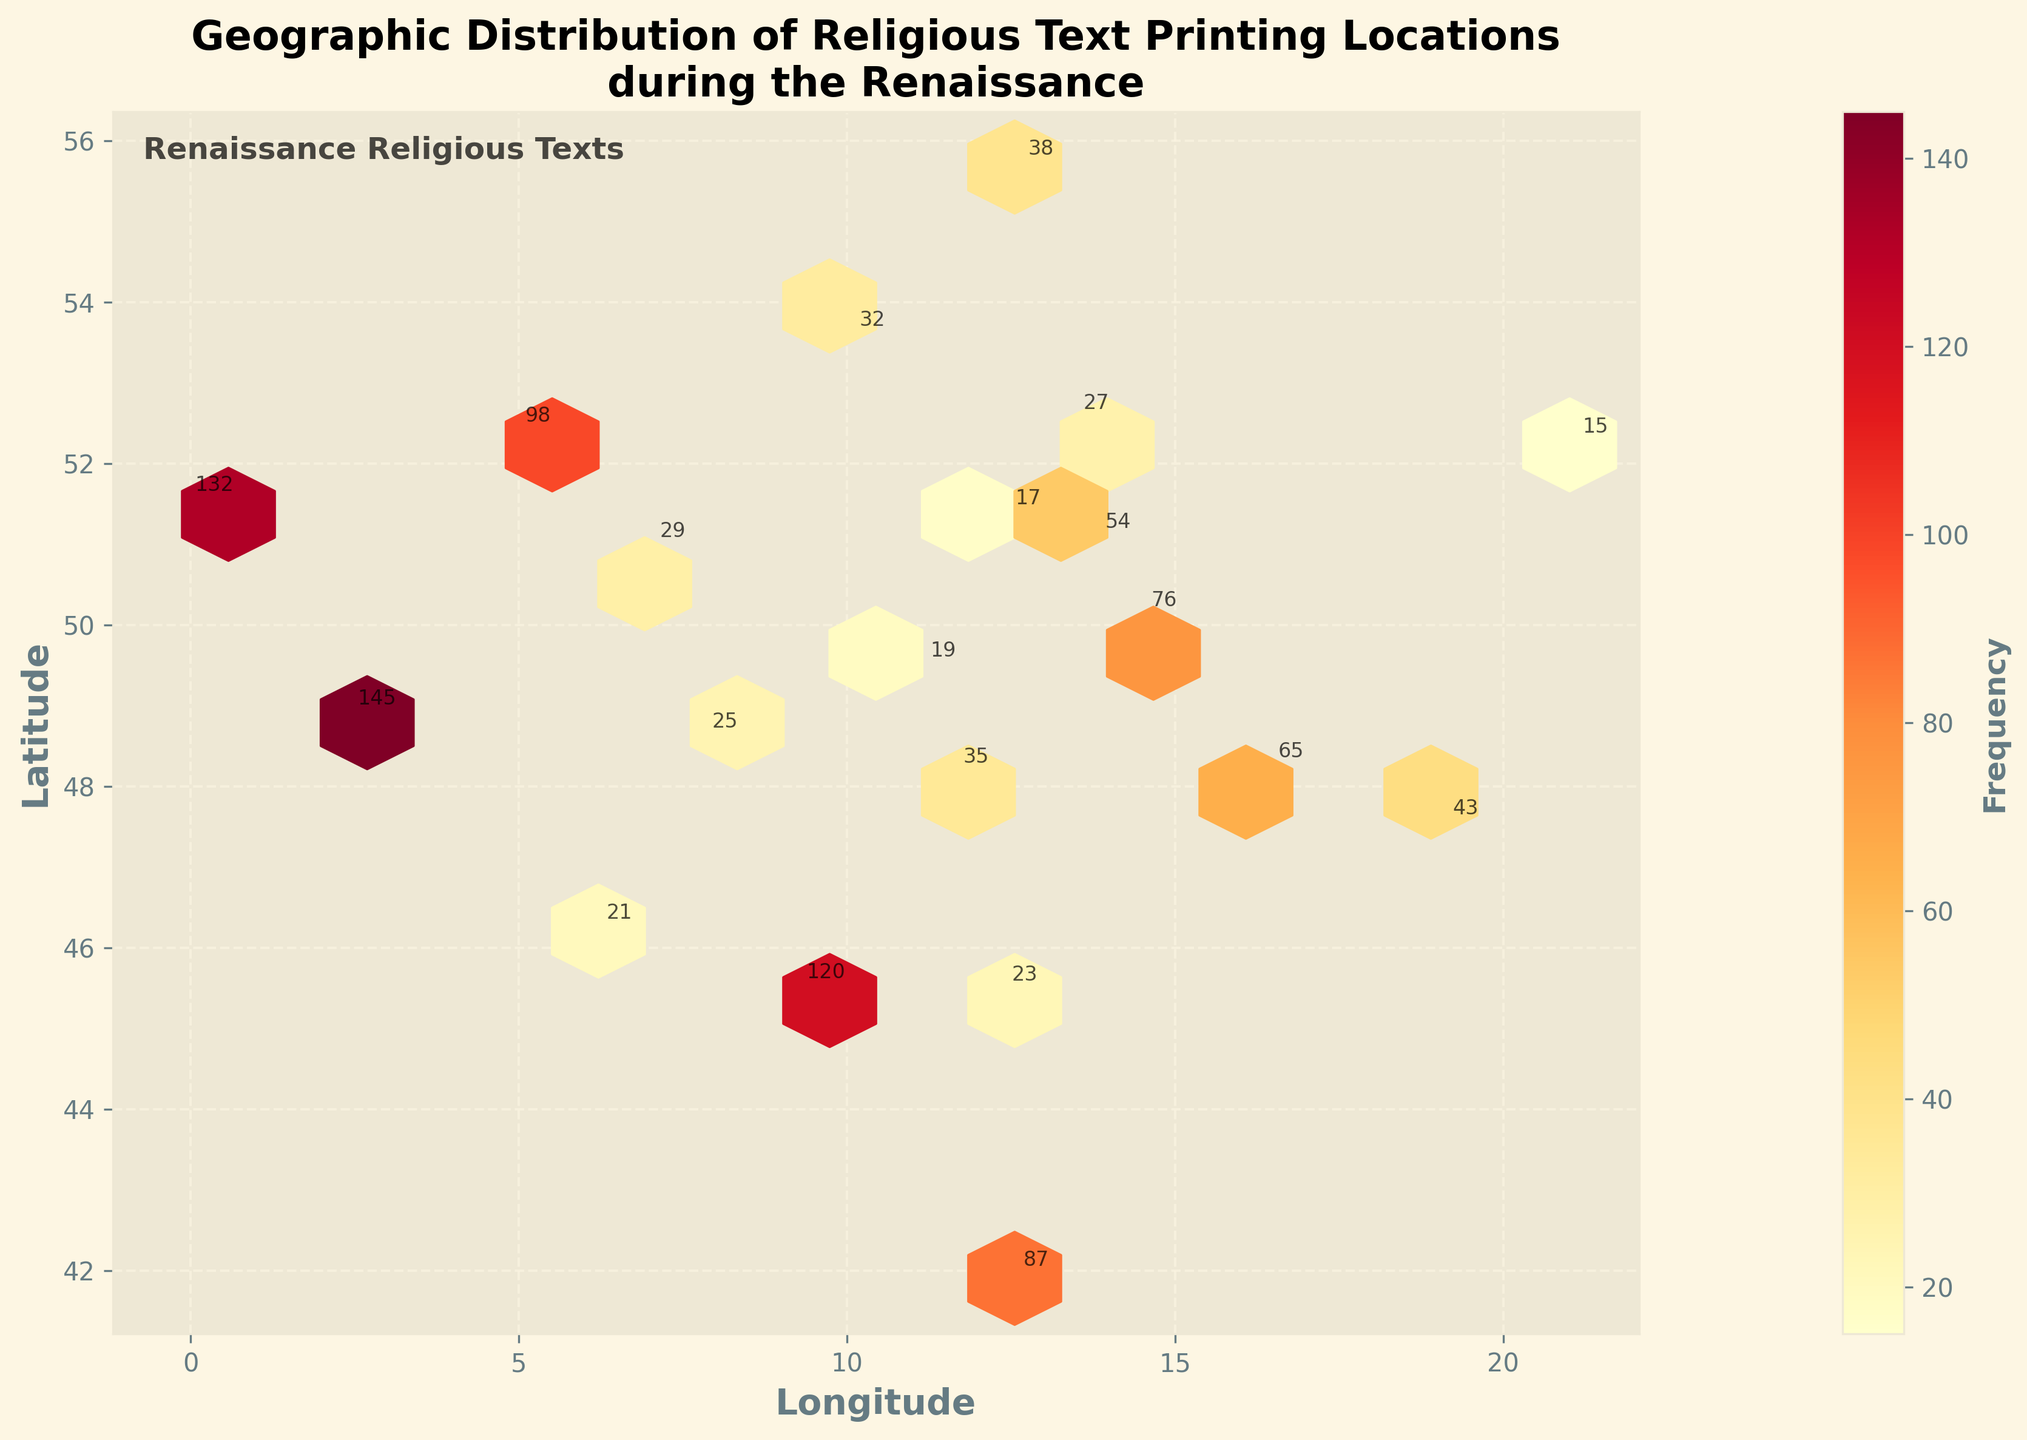What's the title of the figure? The title of the figure is prominently shown at the top.
Answer: Geographic Distribution of Religious Text Printing Locations during the Renaissance What does the colorbar represent? The colorbar indicates the frequency of religious texts printed at each location. It uses a gradient scale from light yellow (low frequency) to dark red (high frequency).
Answer: Frequency Which city has the highest frequency of printed religious texts? By looking at the highest color intensity (darkest red) and the city annotations, Paris (48.8566, 2.3522) has the highest frequency of 145.
Answer: Paris How many cities have a frequency of over 100? By checking the annotations for frequencies over 100, there are three cities: Paris (145), London (132), and Milan (120).
Answer: 3 Is there a city on the list with less than 20 printed texts? If yes, name one. By checking the frequency annotations, there is a city with less than 20 printed texts, such as Nuremberg (19).
Answer: Nuremberg Which latitude range contains the most densely packed printing locations? The densest cluster of hexagons appears between latitudes roughly 40 and 55 degrees, centered around cities like Paris and London.
Answer: 40-55 degrees What city is closest to the coordinate (41.9028, 12.4964), and what is its frequency? The city at this coordinate is Rome, as indicated by the annotation for the frequency. Rome has a frequency of 87.
Answer: Rome, 87 Which geographic direction has the highest number of printing press locations, east or west of the Prime Meridian (0° Longitude)? More printing press locations are noted to the east of the Prime Meridian, including cities like Paris, Rome, and Milan.
Answer: East Considering both the latitude and longitude, which city is the furthest east on the map? The city with the most eastern longitude in the dataset is Warsaw (21.0122).
Answer: Warsaw What is the average frequency of the cities located at longitudes greater than 10 degrees? Cities with longitudes > 10 degrees are Milan (120), Rome (87), Prague (76), Vienna (65), Budapest (43), Copenhagen (38), Munich (35), Venice (23), Geneva (21), and Warsaw (15). Sum their frequencies (120 + 87 + 76 + 65 + 43 + 38 + 35 + 23 + 21 + 15) to get 523. There are 10 cities, so the average is 523/10 = 52.3
Answer: 52.3 Which city has the highest latitude and what is its frequency? The city with the highest latitude is Copenhagen (55.6761, 12.5683), with a frequency of 38.
Answer: Copenhagen, 38 